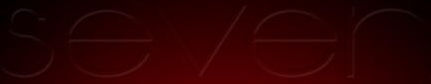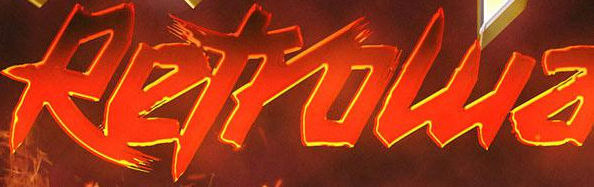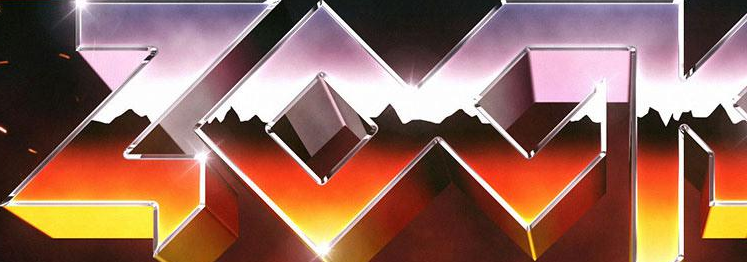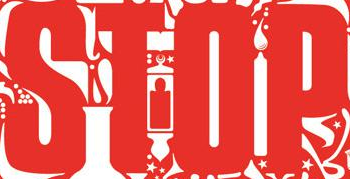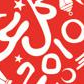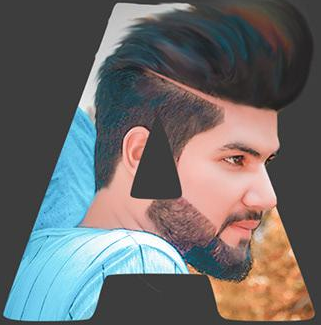What text appears in these images from left to right, separated by a semicolon? sever; Retrowa; ZOCK; STOP; 2010; A 